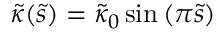<formula> <loc_0><loc_0><loc_500><loc_500>\tilde { \kappa } ( \tilde { s } ) = \tilde { \kappa } _ { 0 } \sin \left ( \pi \tilde { s } \right )</formula> 